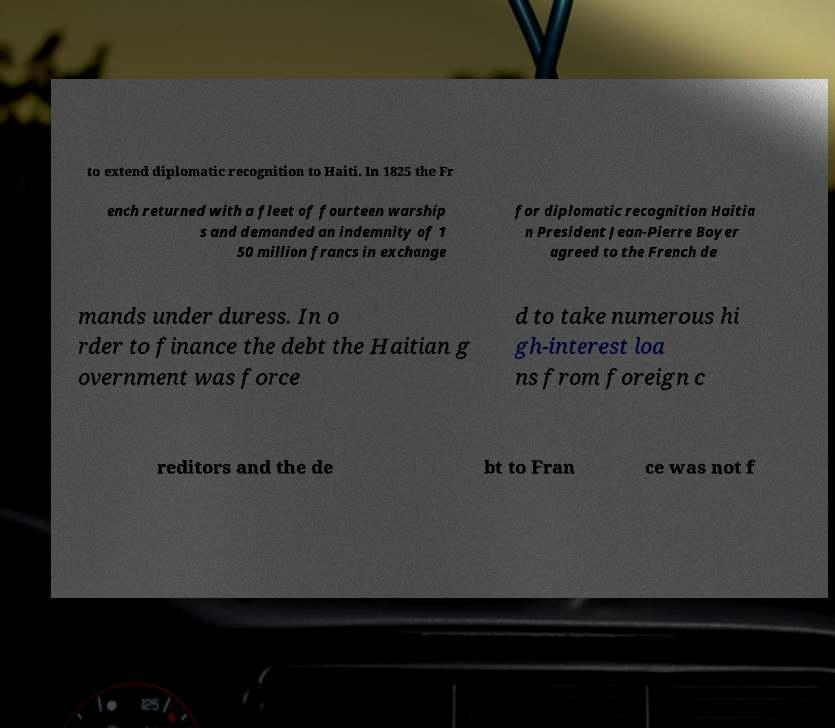There's text embedded in this image that I need extracted. Can you transcribe it verbatim? to extend diplomatic recognition to Haiti. In 1825 the Fr ench returned with a fleet of fourteen warship s and demanded an indemnity of 1 50 million francs in exchange for diplomatic recognition Haitia n President Jean-Pierre Boyer agreed to the French de mands under duress. In o rder to finance the debt the Haitian g overnment was force d to take numerous hi gh-interest loa ns from foreign c reditors and the de bt to Fran ce was not f 